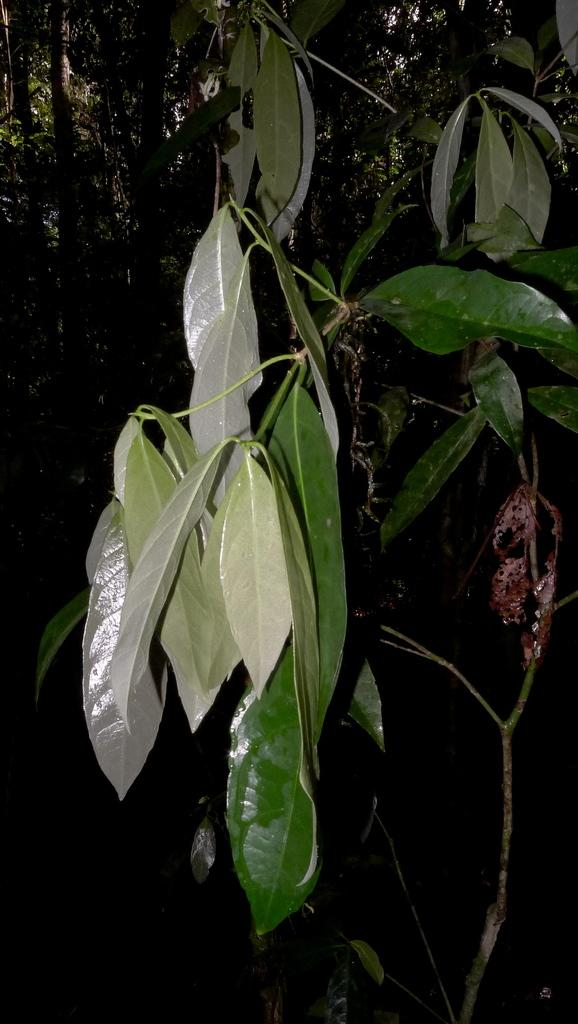Where was the image taken? The image was taken outdoors. What can be seen in the background of the image? There are many trees in the image. What type of plants are visible in the image? There are plants with green leaves in the image. What type of arch can be seen in the image? There is no arch present in the image. Can you describe the facial expressions of the plants in the image? Plants do not have facial expressions, so this cannot be described in the image. 